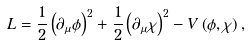<formula> <loc_0><loc_0><loc_500><loc_500>L = \frac { 1 } { 2 } \left ( \partial _ { \mu } \phi \right ) ^ { 2 } + \frac { 1 } { 2 } \left ( \partial _ { \mu } \chi \right ) ^ { 2 } - V \left ( \phi , \chi \right ) ,</formula> 